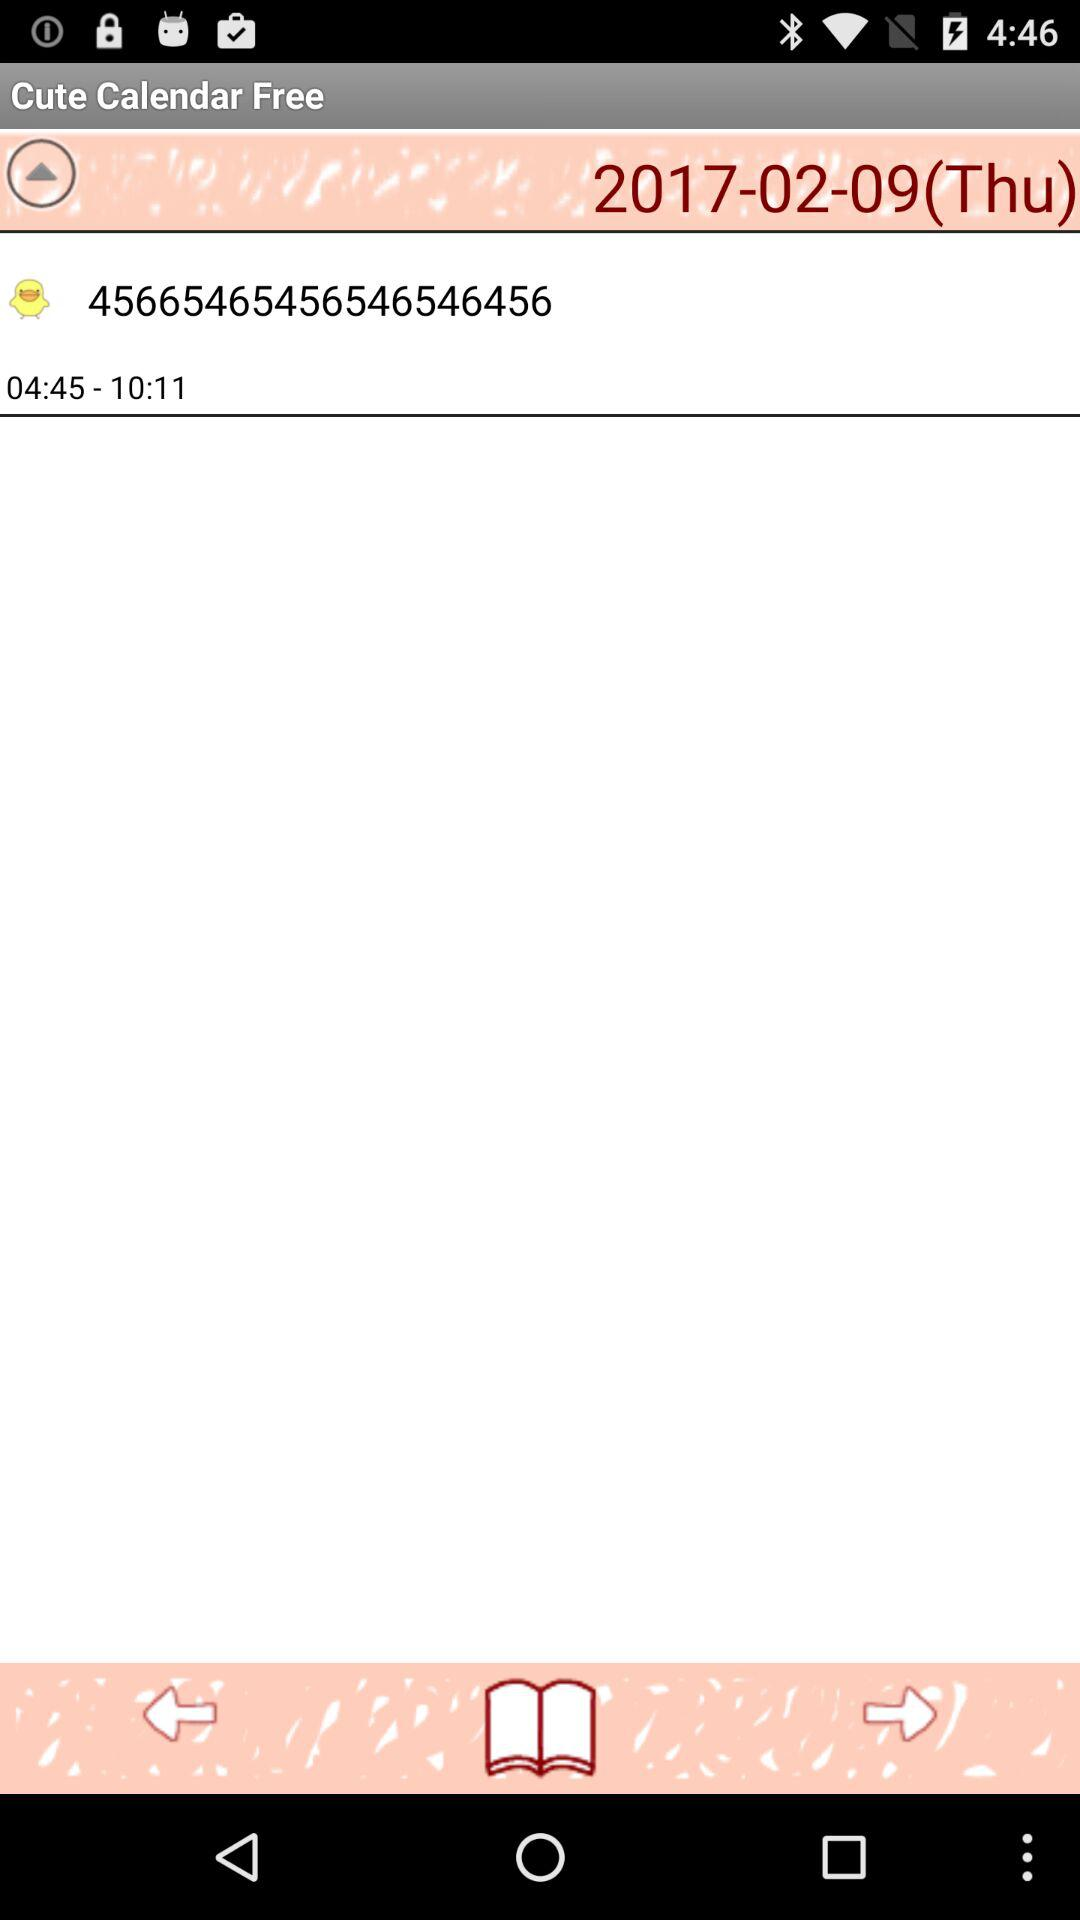What date is set on the calendar? The set date is February 9, 2017. 